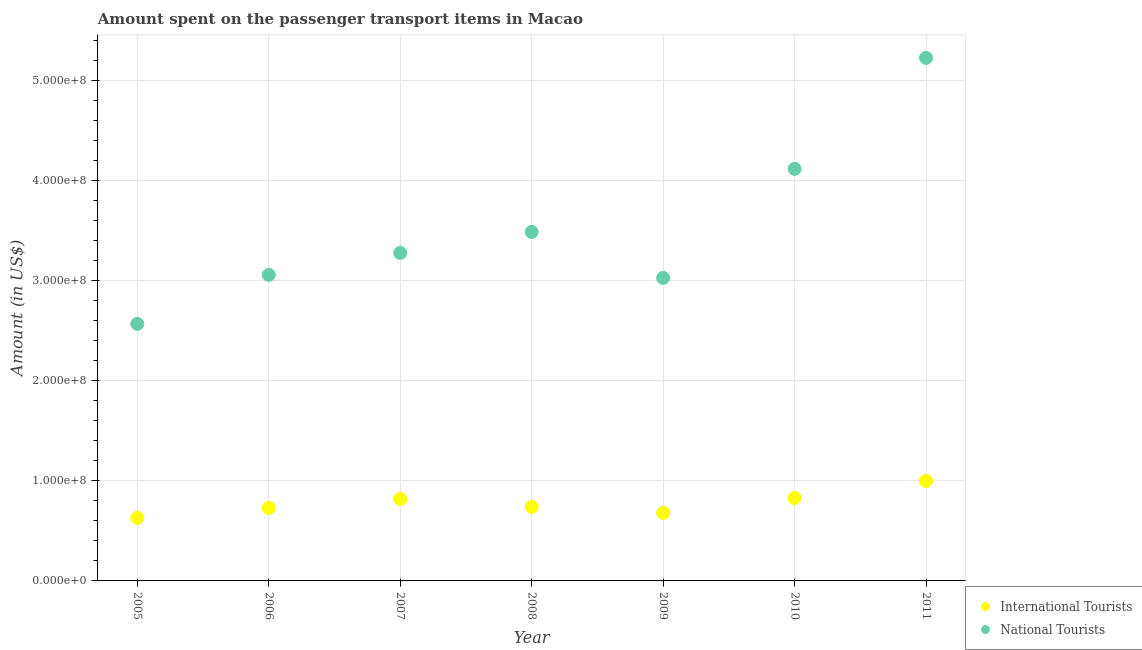What is the amount spent on transport items of international tourists in 2010?
Give a very brief answer. 8.30e+07. Across all years, what is the maximum amount spent on transport items of international tourists?
Provide a succinct answer. 1.00e+08. Across all years, what is the minimum amount spent on transport items of international tourists?
Your response must be concise. 6.30e+07. What is the total amount spent on transport items of international tourists in the graph?
Give a very brief answer. 5.43e+08. What is the difference between the amount spent on transport items of international tourists in 2005 and that in 2007?
Keep it short and to the point. -1.90e+07. What is the difference between the amount spent on transport items of national tourists in 2007 and the amount spent on transport items of international tourists in 2008?
Keep it short and to the point. 2.54e+08. What is the average amount spent on transport items of national tourists per year?
Offer a terse response. 3.54e+08. In the year 2005, what is the difference between the amount spent on transport items of international tourists and amount spent on transport items of national tourists?
Provide a short and direct response. -1.94e+08. What is the ratio of the amount spent on transport items of international tourists in 2005 to that in 2006?
Ensure brevity in your answer.  0.86. Is the amount spent on transport items of national tourists in 2007 less than that in 2010?
Provide a short and direct response. Yes. What is the difference between the highest and the second highest amount spent on transport items of national tourists?
Give a very brief answer. 1.11e+08. What is the difference between the highest and the lowest amount spent on transport items of international tourists?
Your response must be concise. 3.70e+07. In how many years, is the amount spent on transport items of international tourists greater than the average amount spent on transport items of international tourists taken over all years?
Your answer should be compact. 3. Is the sum of the amount spent on transport items of national tourists in 2008 and 2009 greater than the maximum amount spent on transport items of international tourists across all years?
Offer a very short reply. Yes. Is the amount spent on transport items of national tourists strictly greater than the amount spent on transport items of international tourists over the years?
Your answer should be compact. Yes. How many dotlines are there?
Give a very brief answer. 2. Are the values on the major ticks of Y-axis written in scientific E-notation?
Your answer should be very brief. Yes. Where does the legend appear in the graph?
Provide a succinct answer. Bottom right. How are the legend labels stacked?
Your answer should be very brief. Vertical. What is the title of the graph?
Ensure brevity in your answer.  Amount spent on the passenger transport items in Macao. Does "Canada" appear as one of the legend labels in the graph?
Ensure brevity in your answer.  No. What is the label or title of the X-axis?
Offer a terse response. Year. What is the Amount (in US$) in International Tourists in 2005?
Provide a succinct answer. 6.30e+07. What is the Amount (in US$) in National Tourists in 2005?
Ensure brevity in your answer.  2.57e+08. What is the Amount (in US$) in International Tourists in 2006?
Make the answer very short. 7.30e+07. What is the Amount (in US$) in National Tourists in 2006?
Your answer should be compact. 3.06e+08. What is the Amount (in US$) of International Tourists in 2007?
Your answer should be compact. 8.20e+07. What is the Amount (in US$) of National Tourists in 2007?
Your answer should be very brief. 3.28e+08. What is the Amount (in US$) of International Tourists in 2008?
Ensure brevity in your answer.  7.40e+07. What is the Amount (in US$) in National Tourists in 2008?
Ensure brevity in your answer.  3.49e+08. What is the Amount (in US$) of International Tourists in 2009?
Make the answer very short. 6.80e+07. What is the Amount (in US$) of National Tourists in 2009?
Your response must be concise. 3.03e+08. What is the Amount (in US$) in International Tourists in 2010?
Your answer should be compact. 8.30e+07. What is the Amount (in US$) of National Tourists in 2010?
Keep it short and to the point. 4.12e+08. What is the Amount (in US$) in International Tourists in 2011?
Offer a terse response. 1.00e+08. What is the Amount (in US$) in National Tourists in 2011?
Ensure brevity in your answer.  5.23e+08. Across all years, what is the maximum Amount (in US$) in National Tourists?
Provide a succinct answer. 5.23e+08. Across all years, what is the minimum Amount (in US$) in International Tourists?
Provide a short and direct response. 6.30e+07. Across all years, what is the minimum Amount (in US$) of National Tourists?
Offer a terse response. 2.57e+08. What is the total Amount (in US$) in International Tourists in the graph?
Your answer should be very brief. 5.43e+08. What is the total Amount (in US$) of National Tourists in the graph?
Your answer should be compact. 2.48e+09. What is the difference between the Amount (in US$) in International Tourists in 2005 and that in 2006?
Offer a very short reply. -1.00e+07. What is the difference between the Amount (in US$) of National Tourists in 2005 and that in 2006?
Your answer should be very brief. -4.90e+07. What is the difference between the Amount (in US$) of International Tourists in 2005 and that in 2007?
Your answer should be very brief. -1.90e+07. What is the difference between the Amount (in US$) of National Tourists in 2005 and that in 2007?
Provide a succinct answer. -7.10e+07. What is the difference between the Amount (in US$) of International Tourists in 2005 and that in 2008?
Ensure brevity in your answer.  -1.10e+07. What is the difference between the Amount (in US$) in National Tourists in 2005 and that in 2008?
Your response must be concise. -9.20e+07. What is the difference between the Amount (in US$) in International Tourists in 2005 and that in 2009?
Make the answer very short. -5.00e+06. What is the difference between the Amount (in US$) of National Tourists in 2005 and that in 2009?
Give a very brief answer. -4.60e+07. What is the difference between the Amount (in US$) in International Tourists in 2005 and that in 2010?
Keep it short and to the point. -2.00e+07. What is the difference between the Amount (in US$) of National Tourists in 2005 and that in 2010?
Provide a succinct answer. -1.55e+08. What is the difference between the Amount (in US$) in International Tourists in 2005 and that in 2011?
Provide a succinct answer. -3.70e+07. What is the difference between the Amount (in US$) in National Tourists in 2005 and that in 2011?
Your answer should be very brief. -2.66e+08. What is the difference between the Amount (in US$) of International Tourists in 2006 and that in 2007?
Provide a short and direct response. -9.00e+06. What is the difference between the Amount (in US$) in National Tourists in 2006 and that in 2007?
Give a very brief answer. -2.20e+07. What is the difference between the Amount (in US$) in National Tourists in 2006 and that in 2008?
Your answer should be compact. -4.30e+07. What is the difference between the Amount (in US$) of National Tourists in 2006 and that in 2009?
Provide a succinct answer. 3.00e+06. What is the difference between the Amount (in US$) in International Tourists in 2006 and that in 2010?
Make the answer very short. -1.00e+07. What is the difference between the Amount (in US$) in National Tourists in 2006 and that in 2010?
Provide a succinct answer. -1.06e+08. What is the difference between the Amount (in US$) of International Tourists in 2006 and that in 2011?
Your answer should be compact. -2.70e+07. What is the difference between the Amount (in US$) of National Tourists in 2006 and that in 2011?
Provide a succinct answer. -2.17e+08. What is the difference between the Amount (in US$) of International Tourists in 2007 and that in 2008?
Provide a short and direct response. 8.00e+06. What is the difference between the Amount (in US$) of National Tourists in 2007 and that in 2008?
Ensure brevity in your answer.  -2.10e+07. What is the difference between the Amount (in US$) of International Tourists in 2007 and that in 2009?
Give a very brief answer. 1.40e+07. What is the difference between the Amount (in US$) of National Tourists in 2007 and that in 2009?
Make the answer very short. 2.50e+07. What is the difference between the Amount (in US$) of National Tourists in 2007 and that in 2010?
Offer a very short reply. -8.40e+07. What is the difference between the Amount (in US$) in International Tourists in 2007 and that in 2011?
Your response must be concise. -1.80e+07. What is the difference between the Amount (in US$) in National Tourists in 2007 and that in 2011?
Provide a short and direct response. -1.95e+08. What is the difference between the Amount (in US$) in National Tourists in 2008 and that in 2009?
Keep it short and to the point. 4.60e+07. What is the difference between the Amount (in US$) of International Tourists in 2008 and that in 2010?
Your answer should be compact. -9.00e+06. What is the difference between the Amount (in US$) of National Tourists in 2008 and that in 2010?
Your response must be concise. -6.30e+07. What is the difference between the Amount (in US$) in International Tourists in 2008 and that in 2011?
Provide a succinct answer. -2.60e+07. What is the difference between the Amount (in US$) in National Tourists in 2008 and that in 2011?
Provide a short and direct response. -1.74e+08. What is the difference between the Amount (in US$) in International Tourists in 2009 and that in 2010?
Provide a succinct answer. -1.50e+07. What is the difference between the Amount (in US$) of National Tourists in 2009 and that in 2010?
Your response must be concise. -1.09e+08. What is the difference between the Amount (in US$) of International Tourists in 2009 and that in 2011?
Ensure brevity in your answer.  -3.20e+07. What is the difference between the Amount (in US$) of National Tourists in 2009 and that in 2011?
Make the answer very short. -2.20e+08. What is the difference between the Amount (in US$) of International Tourists in 2010 and that in 2011?
Provide a short and direct response. -1.70e+07. What is the difference between the Amount (in US$) in National Tourists in 2010 and that in 2011?
Give a very brief answer. -1.11e+08. What is the difference between the Amount (in US$) in International Tourists in 2005 and the Amount (in US$) in National Tourists in 2006?
Offer a very short reply. -2.43e+08. What is the difference between the Amount (in US$) of International Tourists in 2005 and the Amount (in US$) of National Tourists in 2007?
Offer a very short reply. -2.65e+08. What is the difference between the Amount (in US$) of International Tourists in 2005 and the Amount (in US$) of National Tourists in 2008?
Offer a terse response. -2.86e+08. What is the difference between the Amount (in US$) in International Tourists in 2005 and the Amount (in US$) in National Tourists in 2009?
Your answer should be compact. -2.40e+08. What is the difference between the Amount (in US$) in International Tourists in 2005 and the Amount (in US$) in National Tourists in 2010?
Your answer should be very brief. -3.49e+08. What is the difference between the Amount (in US$) in International Tourists in 2005 and the Amount (in US$) in National Tourists in 2011?
Your answer should be compact. -4.60e+08. What is the difference between the Amount (in US$) in International Tourists in 2006 and the Amount (in US$) in National Tourists in 2007?
Ensure brevity in your answer.  -2.55e+08. What is the difference between the Amount (in US$) of International Tourists in 2006 and the Amount (in US$) of National Tourists in 2008?
Your answer should be very brief. -2.76e+08. What is the difference between the Amount (in US$) of International Tourists in 2006 and the Amount (in US$) of National Tourists in 2009?
Your response must be concise. -2.30e+08. What is the difference between the Amount (in US$) in International Tourists in 2006 and the Amount (in US$) in National Tourists in 2010?
Provide a short and direct response. -3.39e+08. What is the difference between the Amount (in US$) in International Tourists in 2006 and the Amount (in US$) in National Tourists in 2011?
Ensure brevity in your answer.  -4.50e+08. What is the difference between the Amount (in US$) in International Tourists in 2007 and the Amount (in US$) in National Tourists in 2008?
Ensure brevity in your answer.  -2.67e+08. What is the difference between the Amount (in US$) of International Tourists in 2007 and the Amount (in US$) of National Tourists in 2009?
Ensure brevity in your answer.  -2.21e+08. What is the difference between the Amount (in US$) in International Tourists in 2007 and the Amount (in US$) in National Tourists in 2010?
Offer a terse response. -3.30e+08. What is the difference between the Amount (in US$) in International Tourists in 2007 and the Amount (in US$) in National Tourists in 2011?
Offer a very short reply. -4.41e+08. What is the difference between the Amount (in US$) in International Tourists in 2008 and the Amount (in US$) in National Tourists in 2009?
Give a very brief answer. -2.29e+08. What is the difference between the Amount (in US$) of International Tourists in 2008 and the Amount (in US$) of National Tourists in 2010?
Your answer should be compact. -3.38e+08. What is the difference between the Amount (in US$) of International Tourists in 2008 and the Amount (in US$) of National Tourists in 2011?
Ensure brevity in your answer.  -4.49e+08. What is the difference between the Amount (in US$) in International Tourists in 2009 and the Amount (in US$) in National Tourists in 2010?
Offer a terse response. -3.44e+08. What is the difference between the Amount (in US$) of International Tourists in 2009 and the Amount (in US$) of National Tourists in 2011?
Offer a terse response. -4.55e+08. What is the difference between the Amount (in US$) in International Tourists in 2010 and the Amount (in US$) in National Tourists in 2011?
Provide a succinct answer. -4.40e+08. What is the average Amount (in US$) in International Tourists per year?
Provide a succinct answer. 7.76e+07. What is the average Amount (in US$) of National Tourists per year?
Offer a very short reply. 3.54e+08. In the year 2005, what is the difference between the Amount (in US$) of International Tourists and Amount (in US$) of National Tourists?
Keep it short and to the point. -1.94e+08. In the year 2006, what is the difference between the Amount (in US$) of International Tourists and Amount (in US$) of National Tourists?
Ensure brevity in your answer.  -2.33e+08. In the year 2007, what is the difference between the Amount (in US$) in International Tourists and Amount (in US$) in National Tourists?
Your answer should be very brief. -2.46e+08. In the year 2008, what is the difference between the Amount (in US$) in International Tourists and Amount (in US$) in National Tourists?
Offer a terse response. -2.75e+08. In the year 2009, what is the difference between the Amount (in US$) in International Tourists and Amount (in US$) in National Tourists?
Keep it short and to the point. -2.35e+08. In the year 2010, what is the difference between the Amount (in US$) in International Tourists and Amount (in US$) in National Tourists?
Ensure brevity in your answer.  -3.29e+08. In the year 2011, what is the difference between the Amount (in US$) of International Tourists and Amount (in US$) of National Tourists?
Your response must be concise. -4.23e+08. What is the ratio of the Amount (in US$) in International Tourists in 2005 to that in 2006?
Ensure brevity in your answer.  0.86. What is the ratio of the Amount (in US$) in National Tourists in 2005 to that in 2006?
Provide a succinct answer. 0.84. What is the ratio of the Amount (in US$) of International Tourists in 2005 to that in 2007?
Offer a very short reply. 0.77. What is the ratio of the Amount (in US$) in National Tourists in 2005 to that in 2007?
Ensure brevity in your answer.  0.78. What is the ratio of the Amount (in US$) in International Tourists in 2005 to that in 2008?
Offer a very short reply. 0.85. What is the ratio of the Amount (in US$) in National Tourists in 2005 to that in 2008?
Provide a succinct answer. 0.74. What is the ratio of the Amount (in US$) in International Tourists in 2005 to that in 2009?
Provide a succinct answer. 0.93. What is the ratio of the Amount (in US$) in National Tourists in 2005 to that in 2009?
Provide a succinct answer. 0.85. What is the ratio of the Amount (in US$) of International Tourists in 2005 to that in 2010?
Your answer should be very brief. 0.76. What is the ratio of the Amount (in US$) of National Tourists in 2005 to that in 2010?
Provide a succinct answer. 0.62. What is the ratio of the Amount (in US$) of International Tourists in 2005 to that in 2011?
Your answer should be very brief. 0.63. What is the ratio of the Amount (in US$) of National Tourists in 2005 to that in 2011?
Ensure brevity in your answer.  0.49. What is the ratio of the Amount (in US$) of International Tourists in 2006 to that in 2007?
Make the answer very short. 0.89. What is the ratio of the Amount (in US$) in National Tourists in 2006 to that in 2007?
Provide a short and direct response. 0.93. What is the ratio of the Amount (in US$) of International Tourists in 2006 to that in 2008?
Ensure brevity in your answer.  0.99. What is the ratio of the Amount (in US$) of National Tourists in 2006 to that in 2008?
Make the answer very short. 0.88. What is the ratio of the Amount (in US$) in International Tourists in 2006 to that in 2009?
Offer a terse response. 1.07. What is the ratio of the Amount (in US$) in National Tourists in 2006 to that in 2009?
Ensure brevity in your answer.  1.01. What is the ratio of the Amount (in US$) of International Tourists in 2006 to that in 2010?
Give a very brief answer. 0.88. What is the ratio of the Amount (in US$) of National Tourists in 2006 to that in 2010?
Provide a succinct answer. 0.74. What is the ratio of the Amount (in US$) in International Tourists in 2006 to that in 2011?
Offer a very short reply. 0.73. What is the ratio of the Amount (in US$) in National Tourists in 2006 to that in 2011?
Ensure brevity in your answer.  0.59. What is the ratio of the Amount (in US$) in International Tourists in 2007 to that in 2008?
Give a very brief answer. 1.11. What is the ratio of the Amount (in US$) of National Tourists in 2007 to that in 2008?
Keep it short and to the point. 0.94. What is the ratio of the Amount (in US$) in International Tourists in 2007 to that in 2009?
Provide a short and direct response. 1.21. What is the ratio of the Amount (in US$) in National Tourists in 2007 to that in 2009?
Your response must be concise. 1.08. What is the ratio of the Amount (in US$) in International Tourists in 2007 to that in 2010?
Your answer should be very brief. 0.99. What is the ratio of the Amount (in US$) of National Tourists in 2007 to that in 2010?
Your answer should be compact. 0.8. What is the ratio of the Amount (in US$) of International Tourists in 2007 to that in 2011?
Ensure brevity in your answer.  0.82. What is the ratio of the Amount (in US$) in National Tourists in 2007 to that in 2011?
Your answer should be very brief. 0.63. What is the ratio of the Amount (in US$) in International Tourists in 2008 to that in 2009?
Provide a succinct answer. 1.09. What is the ratio of the Amount (in US$) of National Tourists in 2008 to that in 2009?
Give a very brief answer. 1.15. What is the ratio of the Amount (in US$) of International Tourists in 2008 to that in 2010?
Your response must be concise. 0.89. What is the ratio of the Amount (in US$) in National Tourists in 2008 to that in 2010?
Give a very brief answer. 0.85. What is the ratio of the Amount (in US$) of International Tourists in 2008 to that in 2011?
Your answer should be compact. 0.74. What is the ratio of the Amount (in US$) of National Tourists in 2008 to that in 2011?
Your answer should be very brief. 0.67. What is the ratio of the Amount (in US$) of International Tourists in 2009 to that in 2010?
Your answer should be compact. 0.82. What is the ratio of the Amount (in US$) of National Tourists in 2009 to that in 2010?
Ensure brevity in your answer.  0.74. What is the ratio of the Amount (in US$) in International Tourists in 2009 to that in 2011?
Your answer should be very brief. 0.68. What is the ratio of the Amount (in US$) of National Tourists in 2009 to that in 2011?
Make the answer very short. 0.58. What is the ratio of the Amount (in US$) of International Tourists in 2010 to that in 2011?
Offer a very short reply. 0.83. What is the ratio of the Amount (in US$) in National Tourists in 2010 to that in 2011?
Make the answer very short. 0.79. What is the difference between the highest and the second highest Amount (in US$) of International Tourists?
Your answer should be very brief. 1.70e+07. What is the difference between the highest and the second highest Amount (in US$) of National Tourists?
Provide a succinct answer. 1.11e+08. What is the difference between the highest and the lowest Amount (in US$) of International Tourists?
Give a very brief answer. 3.70e+07. What is the difference between the highest and the lowest Amount (in US$) of National Tourists?
Provide a succinct answer. 2.66e+08. 